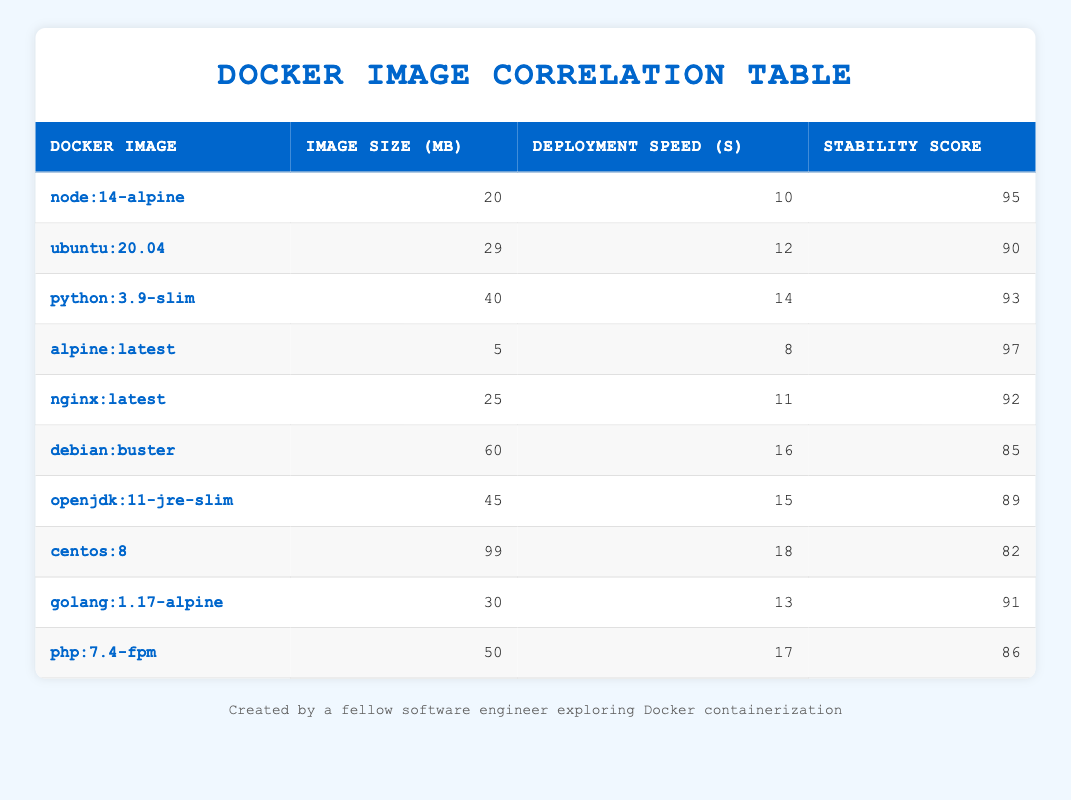What is the size of the alpine:latest Docker image? The table shows that the alpine:latest image has a size of 5 MB.
Answer: 5 MB Which Docker image has the highest stability score? By looking at the stability scores in the table, the alpine:latest image has the highest score of 97.
Answer: alpine:latest What is the average deployment speed for all the Docker images listed? Summing all deployment speeds gives: 10 + 12 + 14 + 8 + 11 + 16 + 15 + 18 + 13 + 17 =  144. There are 10 images, so the average is 144/10 = 14.4 seconds.
Answer: 14.4 seconds Is the stability score of the debian:buster image greater than that of the php:7.4-fpm image? The stability score for debian:buster is 85 and for php:7.4-fpm it is 86. Therefore, 85 is not greater than 86, making the answer false.
Answer: No Which Docker image has the largest size and what is that size? From the table, centos:8 has the largest size of 99 MB, which is listed in the size column.
Answer: 99 MB 